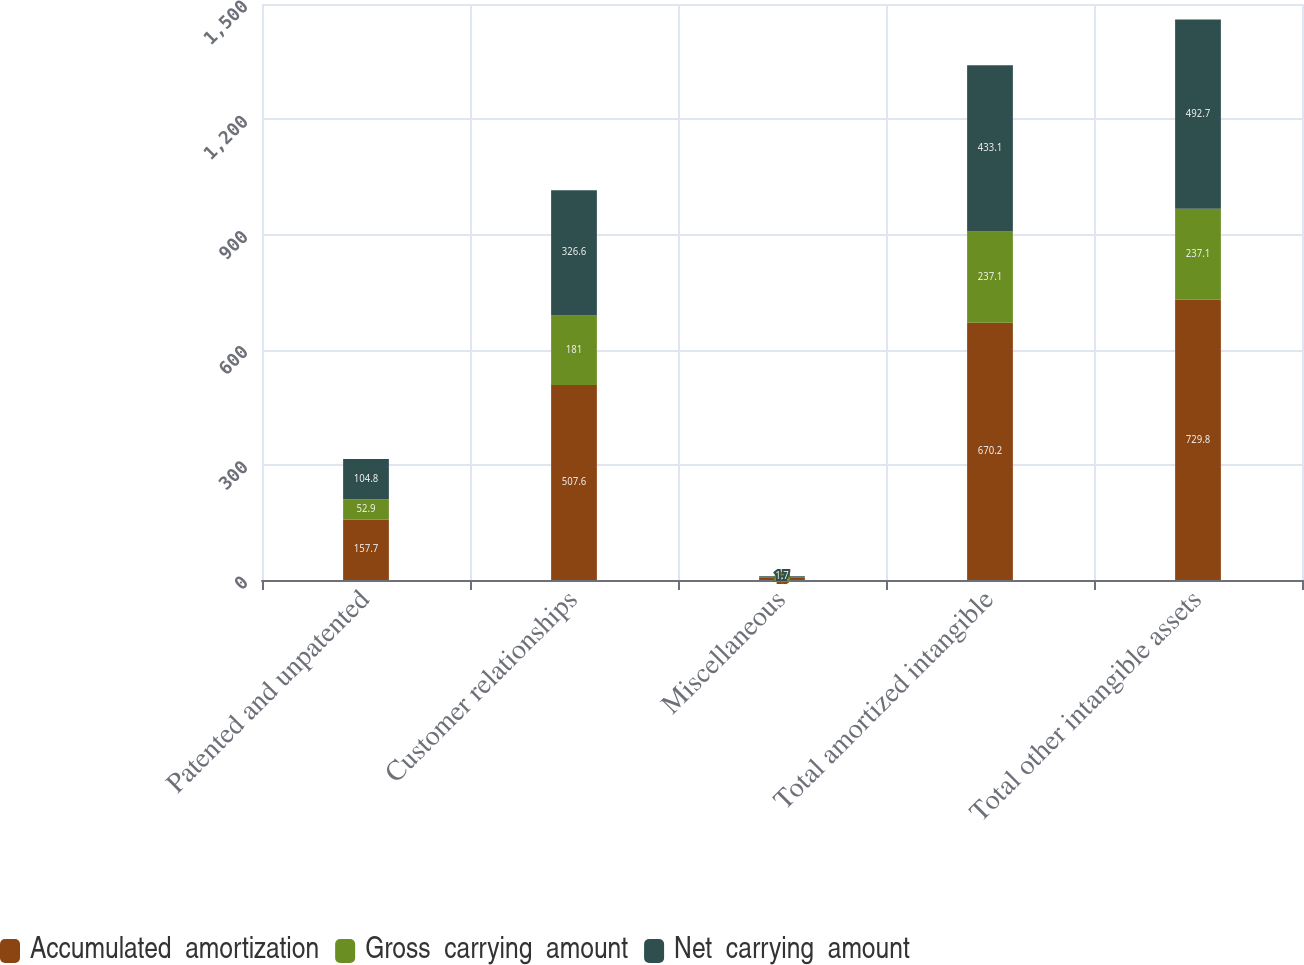<chart> <loc_0><loc_0><loc_500><loc_500><stacked_bar_chart><ecel><fcel>Patented and unpatented<fcel>Customer relationships<fcel>Miscellaneous<fcel>Total amortized intangible<fcel>Total other intangible assets<nl><fcel>Accumulated  amortization<fcel>157.7<fcel>507.6<fcel>4.9<fcel>670.2<fcel>729.8<nl><fcel>Gross  carrying  amount<fcel>52.9<fcel>181<fcel>3.2<fcel>237.1<fcel>237.1<nl><fcel>Net  carrying  amount<fcel>104.8<fcel>326.6<fcel>1.7<fcel>433.1<fcel>492.7<nl></chart> 